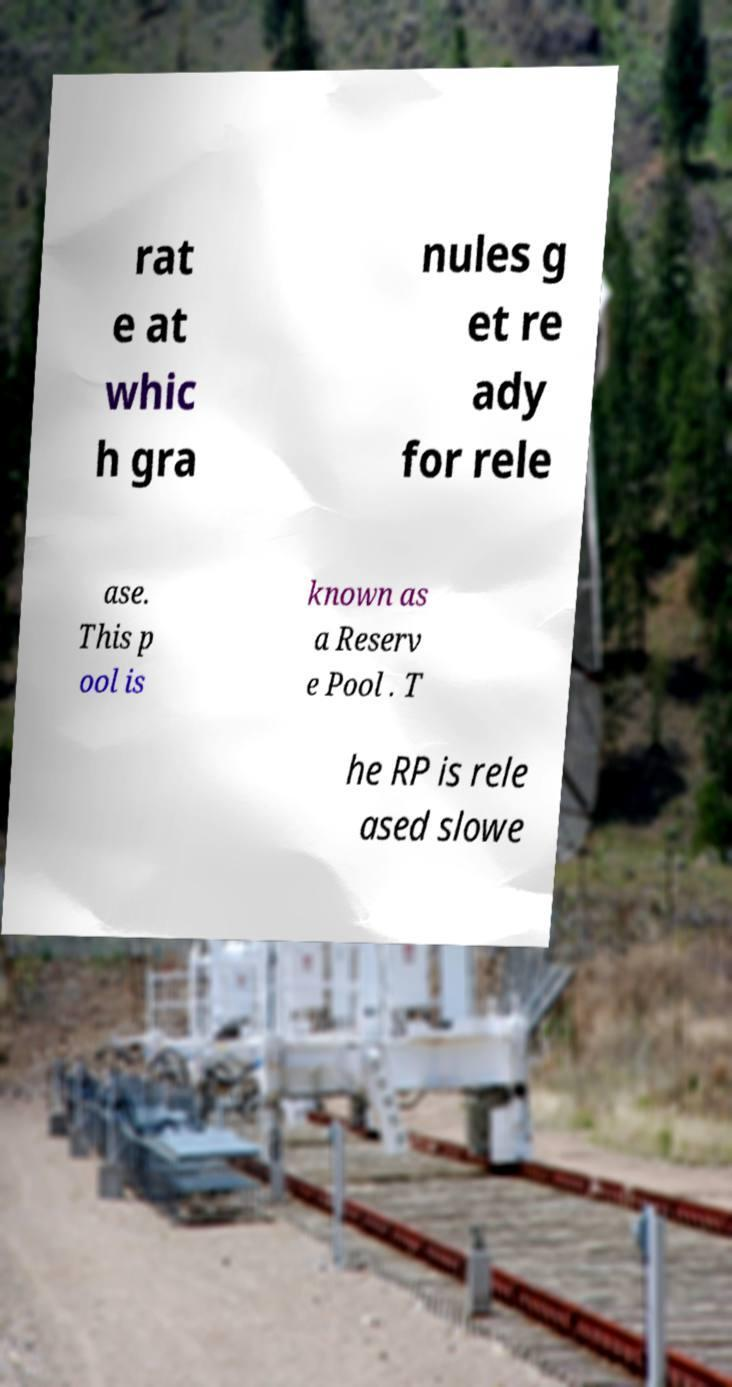Could you extract and type out the text from this image? rat e at whic h gra nules g et re ady for rele ase. This p ool is known as a Reserv e Pool . T he RP is rele ased slowe 